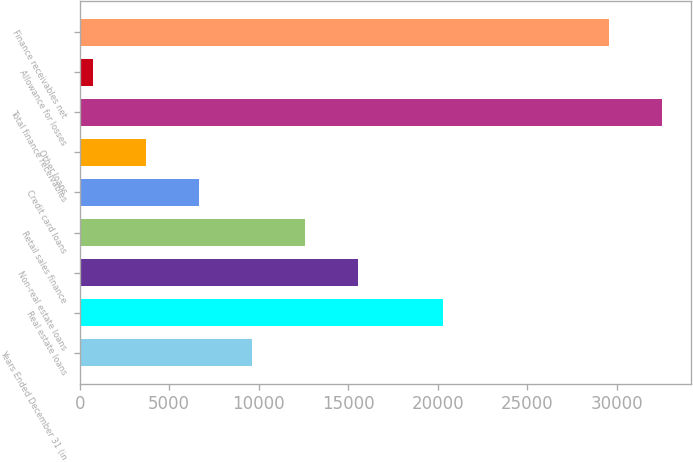Convert chart to OTSL. <chart><loc_0><loc_0><loc_500><loc_500><bar_chart><fcel>Years Ended December 31 (in<fcel>Real estate loans<fcel>Non-real estate loans<fcel>Retail sales finance<fcel>Credit card loans<fcel>Other loans<fcel>Total finance receivables<fcel>Allowance for losses<fcel>Finance receivables net<nl><fcel>9608.9<fcel>20321<fcel>15523.5<fcel>12566.2<fcel>6651.6<fcel>3694.3<fcel>32530.3<fcel>737<fcel>29573<nl></chart> 